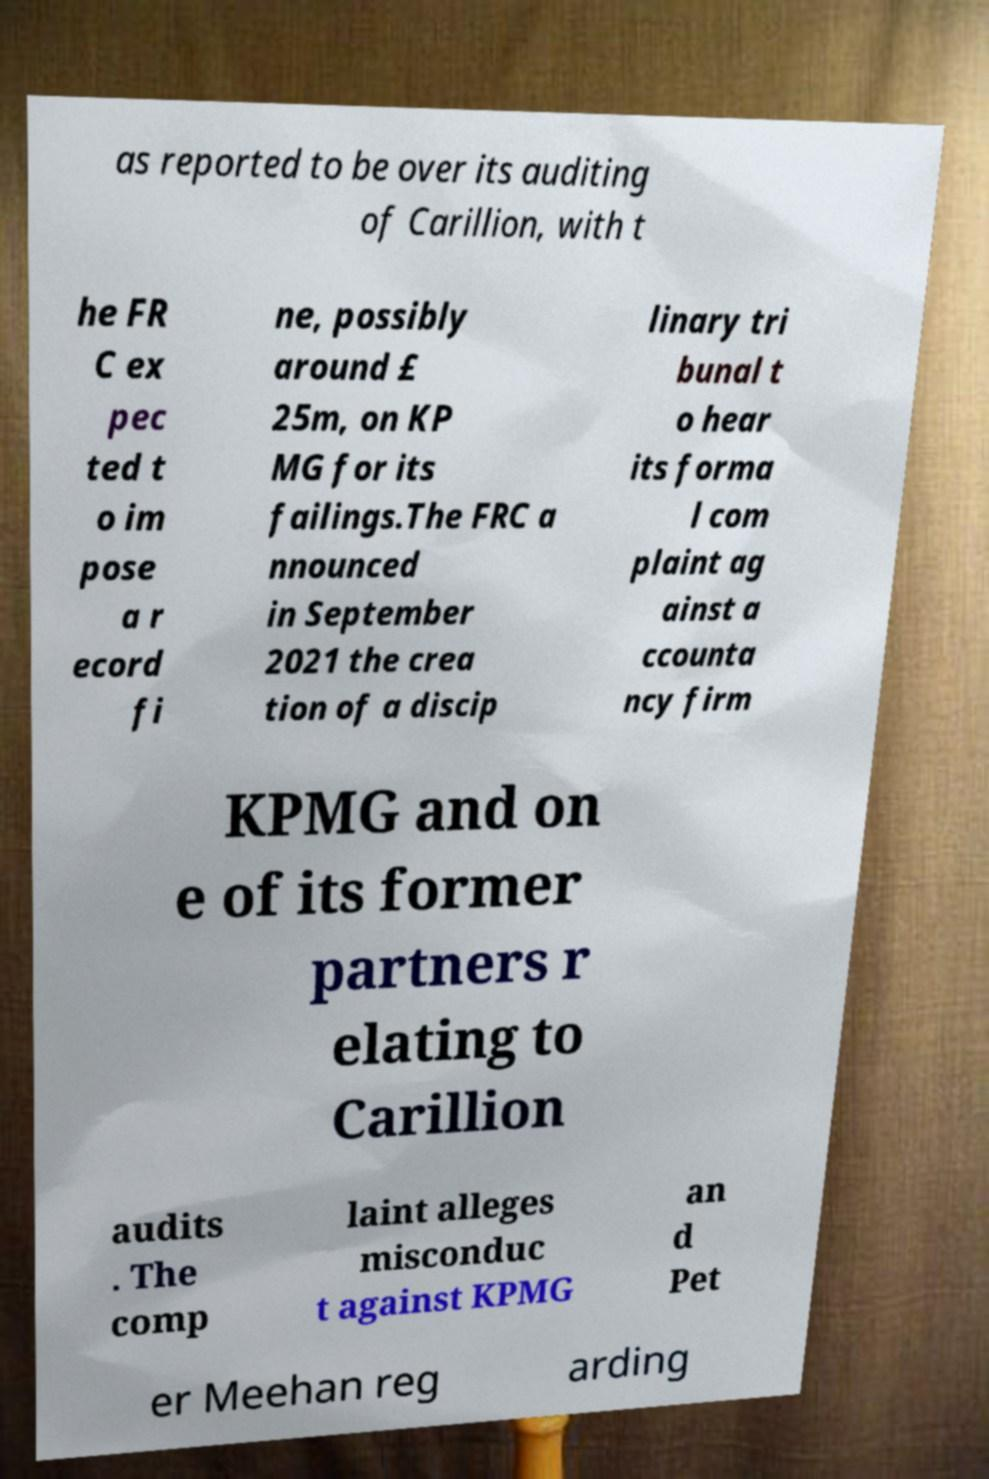Please read and relay the text visible in this image. What does it say? as reported to be over its auditing of Carillion, with t he FR C ex pec ted t o im pose a r ecord fi ne, possibly around £ 25m, on KP MG for its failings.The FRC a nnounced in September 2021 the crea tion of a discip linary tri bunal t o hear its forma l com plaint ag ainst a ccounta ncy firm KPMG and on e of its former partners r elating to Carillion audits . The comp laint alleges misconduc t against KPMG an d Pet er Meehan reg arding 